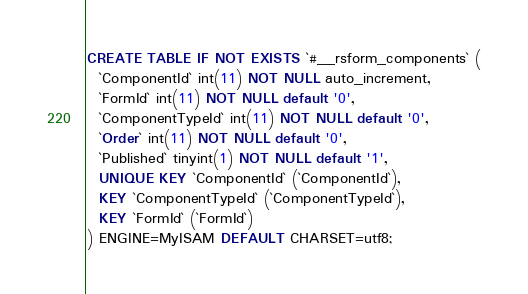Convert code to text. <code><loc_0><loc_0><loc_500><loc_500><_SQL_>CREATE TABLE IF NOT EXISTS `#__rsform_components` (
  `ComponentId` int(11) NOT NULL auto_increment, 
  `FormId` int(11) NOT NULL default '0', 
  `ComponentTypeId` int(11) NOT NULL default '0',
  `Order` int(11) NOT NULL default '0',
  `Published` tinyint(1) NOT NULL default '1',
  UNIQUE KEY `ComponentId` (`ComponentId`),
  KEY `ComponentTypeId` (`ComponentTypeId`),
  KEY `FormId` (`FormId`)
) ENGINE=MyISAM DEFAULT CHARSET=utf8;</code> 